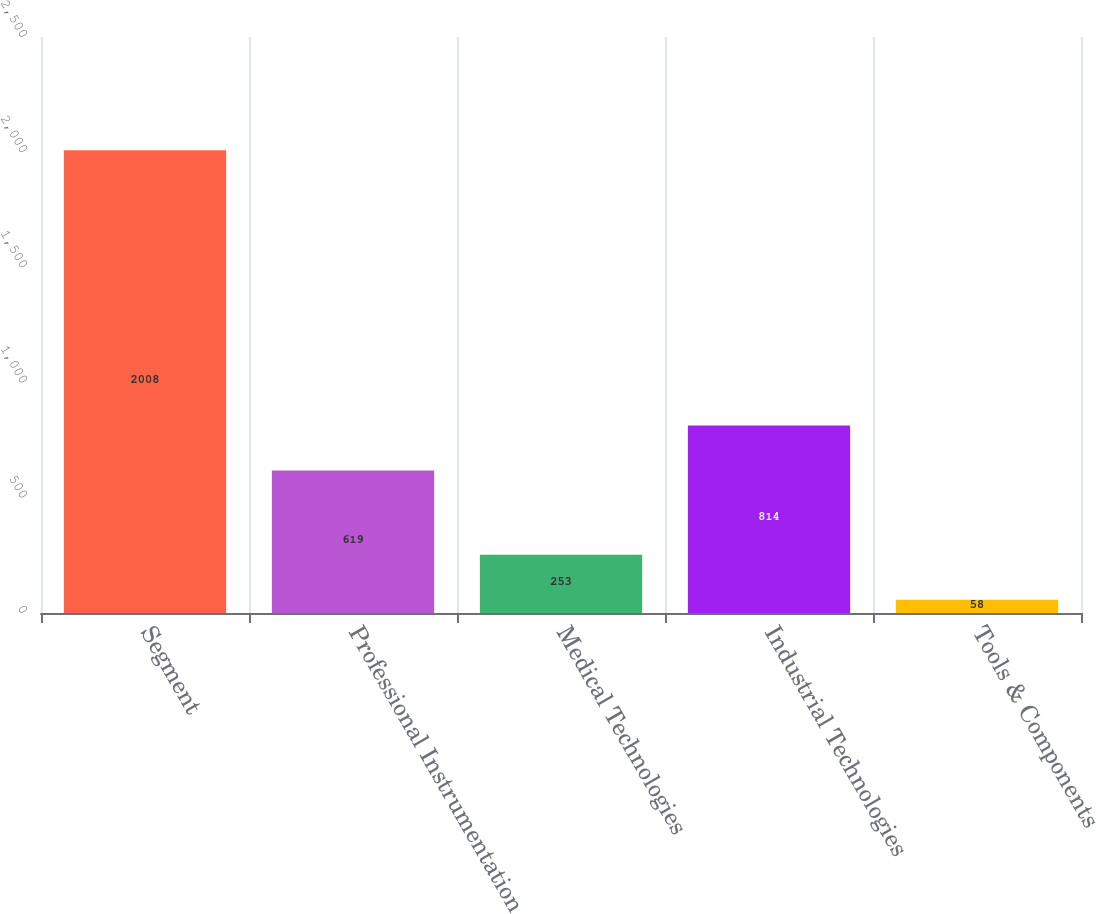Convert chart to OTSL. <chart><loc_0><loc_0><loc_500><loc_500><bar_chart><fcel>Segment<fcel>Professional Instrumentation<fcel>Medical Technologies<fcel>Industrial Technologies<fcel>Tools & Components<nl><fcel>2008<fcel>619<fcel>253<fcel>814<fcel>58<nl></chart> 